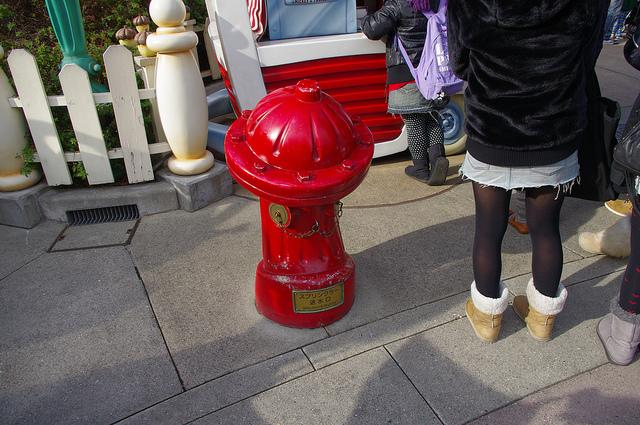What is required to open the flow of water? Please explain your reasoning. wrench. A wrench is needed to open the hydrant. 